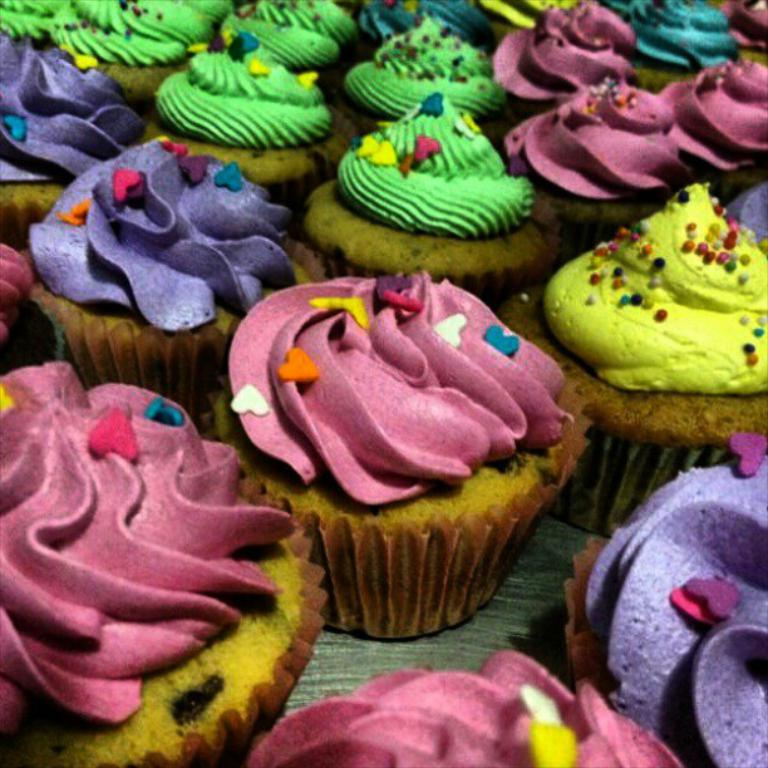What type of food is visible in the image? There are cupcakes in the image. What type of winter activity is depicted in the image? There is no winter activity depicted in the image, as it only features cupcakes. What suggestion is being made in the image? There is no suggestion being made in the image, as it only features cupcakes. 